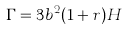Convert formula to latex. <formula><loc_0><loc_0><loc_500><loc_500>\Gamma = 3 b ^ { 2 } ( 1 + r ) H</formula> 